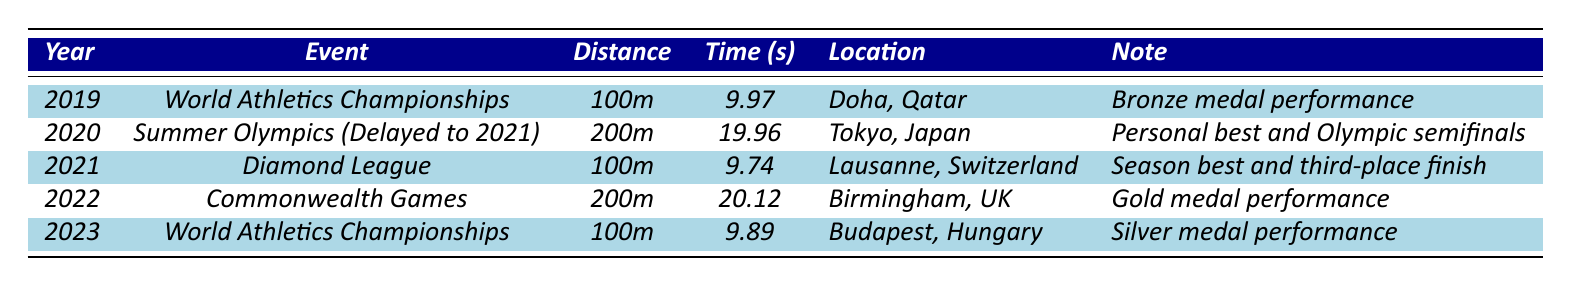What was Andre De Grasse's fastest 100m time recorded in the past 5 years? Looking at the table, the fastest 100m time is 9.74 seconds in 2021 during the Diamond League event.
Answer: 9.74 seconds In which year did Andre De Grasse earn a gold medal? The table indicates that he earned a gold medal in 2022 at the Commonwealth Games.
Answer: 2022 How many times did Andre De Grasse compete in the 100m distance in the given years? Reviewing the table, he competed in the 100m twice: in 2019 (World Athletics Championships) and in 2021 (Diamond League).
Answer: 2 times What is the average time of Andre De Grasse's 200m performances over the last 5 years? He competed in the 200m in 2020 (19.96 seconds) and 2022 (20.12 seconds). The average time is calculated as (19.96 + 20.12) / 2 = 20.04 seconds.
Answer: 20.04 seconds Did Andre De Grasse improve his 100m sprint time from 2019 to 2023? In 2019, his time was 9.97 seconds, and in 2023, it was 9.89 seconds. Since 9.89 is less than 9.97, he improved his time.
Answer: Yes What is the difference between Andre De Grasse's best 200m time and his slowest 200m time over the recorded years? The best time was 19.96 seconds in 2020, and his slowest was 20.12 seconds in 2022. The difference is 20.12 - 19.96 = 0.16 seconds.
Answer: 0.16 seconds In which event did Andre De Grasse achieve his personal best time? He achieved his personal best in the 200m event during the Summer Olympics in 2020 with a time of 19.96 seconds.
Answer: Summer Olympics (2020) Was Andre De Grasse's time in the World Athletics Championships in 2023 better than in 2019? In 2019, his time was 9.97 seconds, and in 2023, it was 9.89 seconds. Since 9.89 is less than 9.97, his 2023 time was better.
Answer: Yes What is the total number of medals Andre De Grasse won in the recorded events? He won a bronze medal in 2019, a gold medal in 2022, and a silver medal in 2023, totaling 3 medals.
Answer: 3 medals How did his performance in the Diamond League compare to his performance in the Commonwealth Games? In the Diamond League (2021), he finished third with a time of 9.74 seconds, while in the Commonwealth Games (2022), he won a gold medal with a 200m time of 20.12 seconds. His performance was better in the Commonwealth Games since he won gold.
Answer: Better performance in Commonwealth Games What location hosted the fastest recorded 100m event for Andre De Grasse? The fastest time (9.74 seconds) was recorded in Lausanne, Switzerland during the Diamond League event in 2021.
Answer: Lausanne, Switzerland 